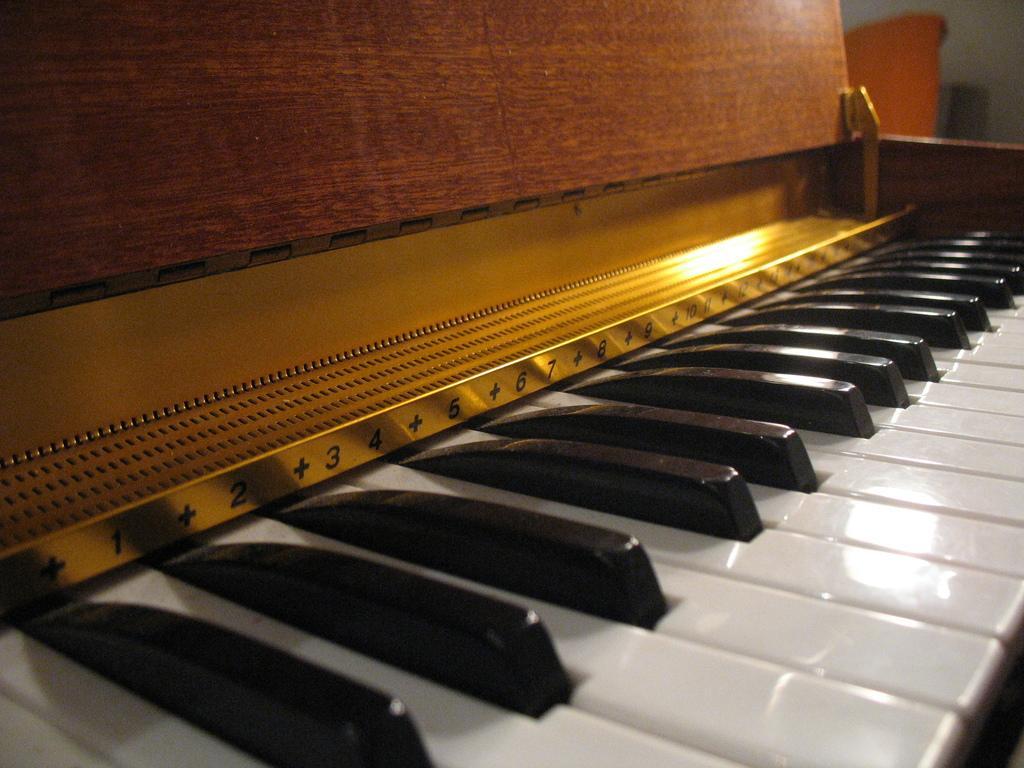Can you describe this image briefly? In this image I can see the piano buttons. 